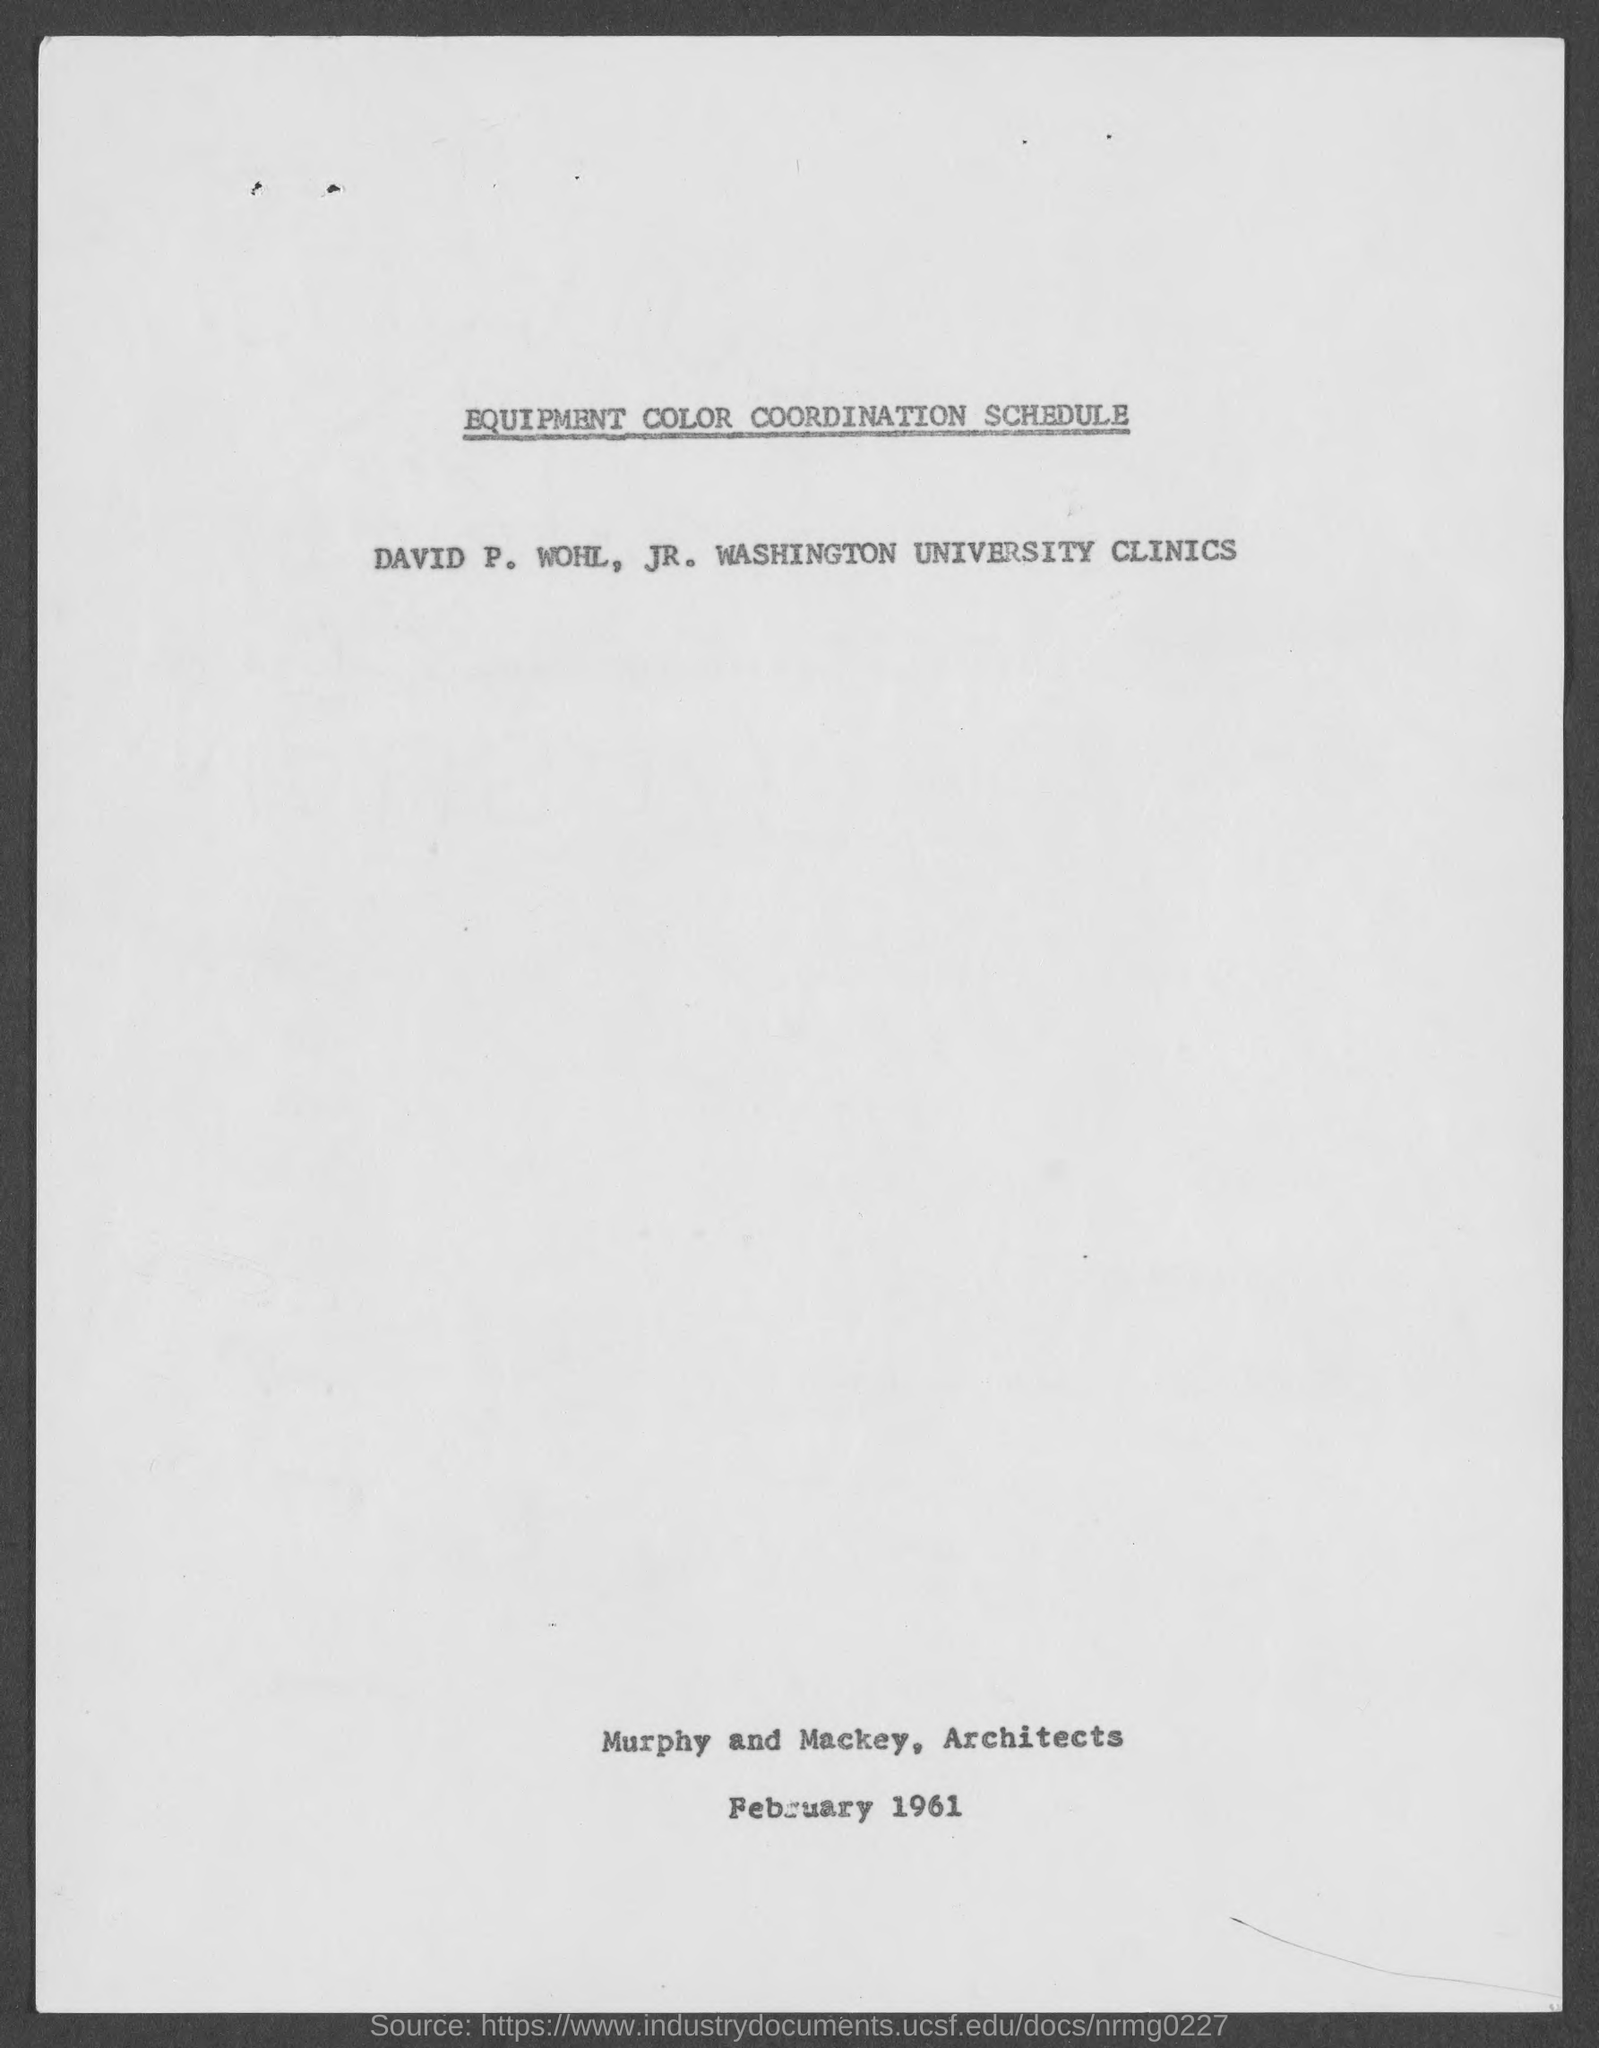What is the date mentioned?
Ensure brevity in your answer.  February 1961. Who are the Architects?
Make the answer very short. Murphy. 